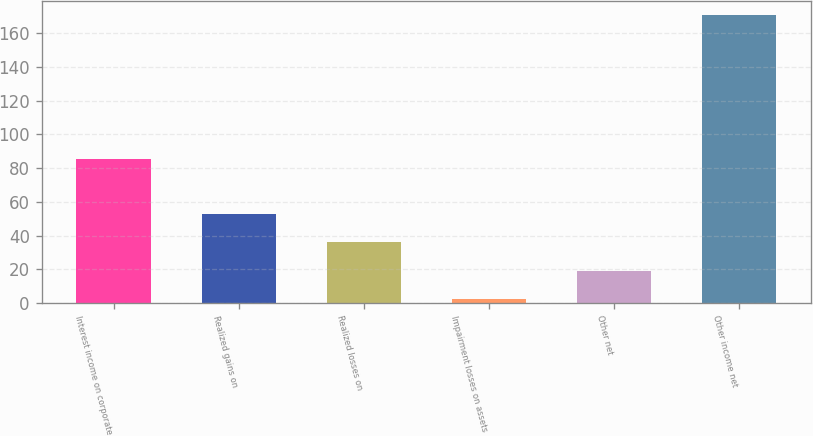Convert chart. <chart><loc_0><loc_0><loc_500><loc_500><bar_chart><fcel>Interest income on corporate<fcel>Realized gains on<fcel>Realized losses on<fcel>Impairment losses on assets<fcel>Other net<fcel>Other income net<nl><fcel>85.2<fcel>52.78<fcel>35.92<fcel>2.2<fcel>19.06<fcel>170.8<nl></chart> 